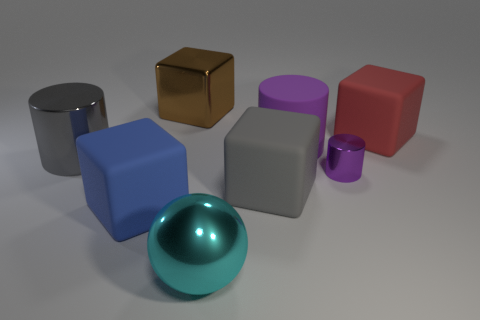This looks like a computer-generated image. Can you identify any specific rendering techniques used? Indeed, the image appears to be computer-generated and might use ray tracing or global illumination rendering techniques to create realistic lighting and shadows. The soft shadows and the subtle light reflections suggest advanced light modeling, which is characteristic of these rendering methods. What could be the purpose of creating such an image? Images like this are often created to showcase rendering capabilities, study object interactions with light, or for compositional practice. They also serve as visual assets in various industries, like architectural visualization, product design, or as placeholders in graphic design and art projects. 